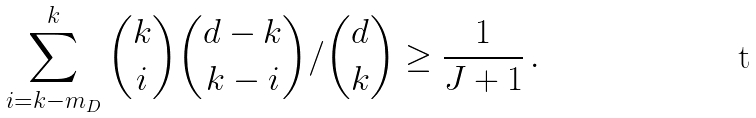<formula> <loc_0><loc_0><loc_500><loc_500>\sum _ { i = k - m _ { D } } ^ { k } { k \choose i } { d - k \choose k - i } / { d \choose k } \geq \frac { 1 } { J + 1 } \, .</formula> 